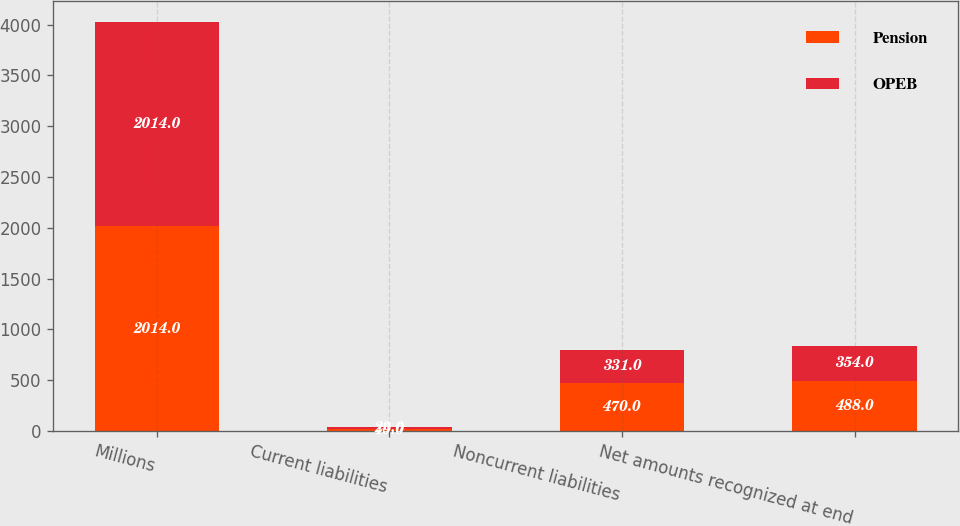Convert chart to OTSL. <chart><loc_0><loc_0><loc_500><loc_500><stacked_bar_chart><ecel><fcel>Millions<fcel>Current liabilities<fcel>Noncurrent liabilities<fcel>Net amounts recognized at end<nl><fcel>Pension<fcel>2014<fcel>19<fcel>470<fcel>488<nl><fcel>OPEB<fcel>2014<fcel>23<fcel>331<fcel>354<nl></chart> 